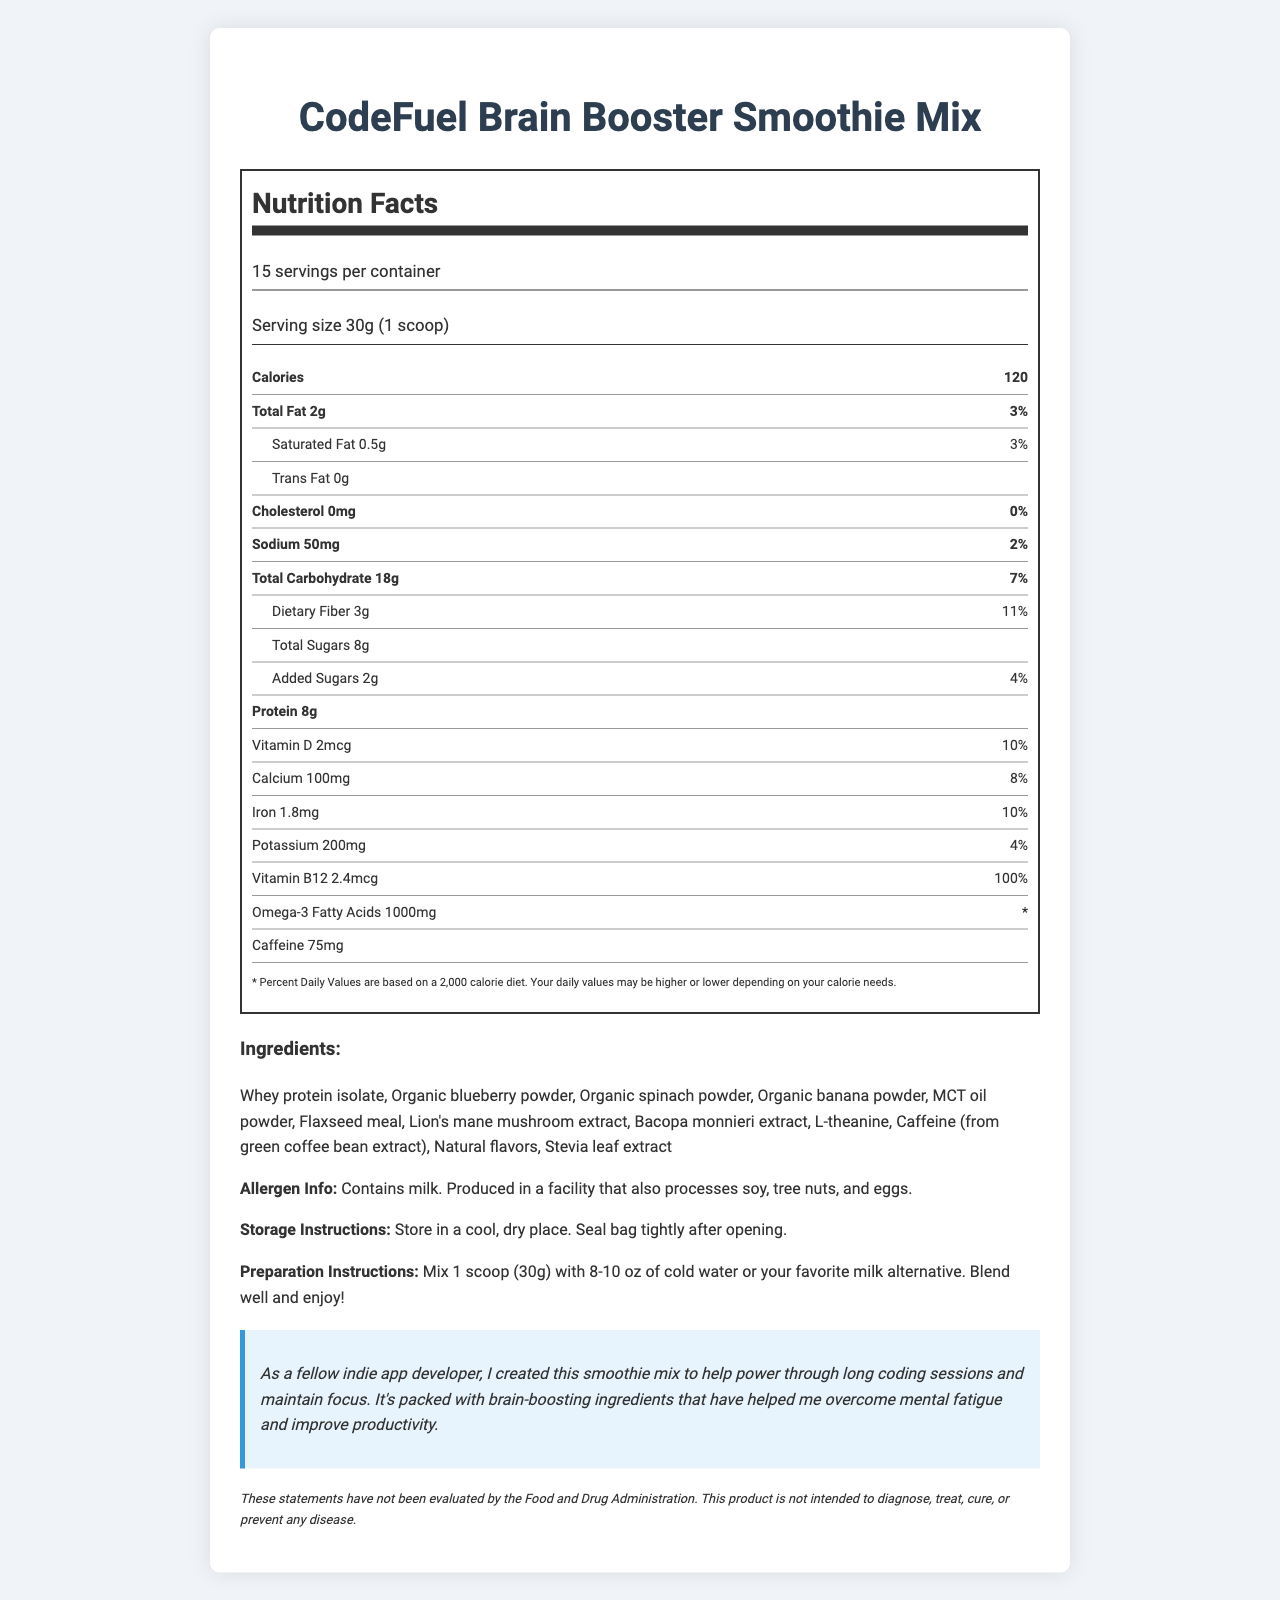what is the serving size? The serving size is explicitly listed as 30g (1 scoop) in the document.
Answer: 30g (1 scoop) how many calories are in one serving? The document lists the calories per serving as 120.
Answer: 120 what is the amount of protein per serving? The amount of protein per serving is stated as 8g in the document.
Answer: 8g does this product contain any trans fat? The document specifies that there are 0g of trans fat.
Answer: No how many servings are there in one container? The document indicates that there are 15 servings per container.
Answer: 15 how much dietary fiber is in one serving? The dietary fiber per serving is listed as 3g.
Answer: 3g what percentage of daily value is the added sugars? The added sugars daily value is listed as 4%.
Answer: 4% how much vitamin B12 is in one serving? The document states that there is 2.4mcg of vitamin B12 per serving.
Answer: 2.4mcg Based on the given serving size, what is the daily value percentage of calcium? The daily value percentage of calcium per serving is shown to be 8%.
Answer: 8% which nutrient listed has the highest daily value percentage? A. Vitamin D B. Iron C. Vitamin B12 D. Sodium The document lists the daily value percentage for Vitamin B12 as 100%, which is higher than the others listed.
Answer: C how much caffeine is there per serving? A. 100mg B. 200mg C. 75mg D. 50mg The document specifies that there are 75mg of caffeine per serving.
Answer: C does the product contain any milk? The allergen information clearly states that the product contains milk.
Answer: Yes is this product intended to diagnose, treat, cure, or prevent any disease? The FDA statement explicitly indicates that the product is not intended to diagnose, treat, cure, or prevent any disease.
Answer: No Briefly describe the main idea of the document. The document mainly focuses on presenting the nutritional facts of the "CodeFuel Brain Booster Smoothie Mix", emphasizing its health benefits and suitability for long coding sessions.
Answer: The document provides detailed nutritional information about a brain-boosting smoothie mix designed for app developers. It lists serving size, nutritional values, ingredients, allergen information, preparation instructions, and includes a note from the developer. what is the daily value percentage of omega-3 fatty acids? The document lists the amount of omega-3 fatty acids as 1000mg, but does not provide a daily value percentage for it.
Answer: Not enough information 